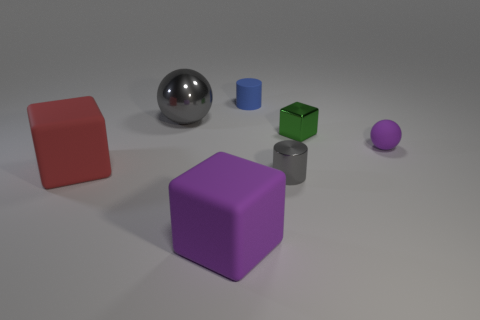Add 3 cyan shiny cubes. How many objects exist? 10 Subtract all cylinders. How many objects are left? 5 Subtract all small cubes. Subtract all red rubber things. How many objects are left? 5 Add 7 big purple cubes. How many big purple cubes are left? 8 Add 7 gray metallic balls. How many gray metallic balls exist? 8 Subtract 1 gray balls. How many objects are left? 6 